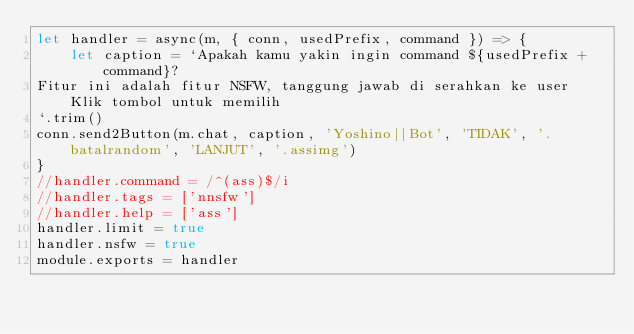Convert code to text. <code><loc_0><loc_0><loc_500><loc_500><_JavaScript_>let handler = async(m, { conn, usedPrefix, command }) => {
    let caption = `Apakah kamu yakin ingin command ${usedPrefix + command}?
Fitur ini adalah fitur NSFW, tanggung jawab di serahkan ke user Klik tombol untuk memilih
`.trim()
conn.send2Button(m.chat, caption, 'Yoshino||Bot', 'TIDAK', '.batalrandom', 'LANJUT', '.assimg')
}
//handler.command = /^(ass)$/i
//handler.tags = ['nnsfw']
//handler.help = ['ass']
handler.limit = true
handler.nsfw = true
module.exports = handler</code> 